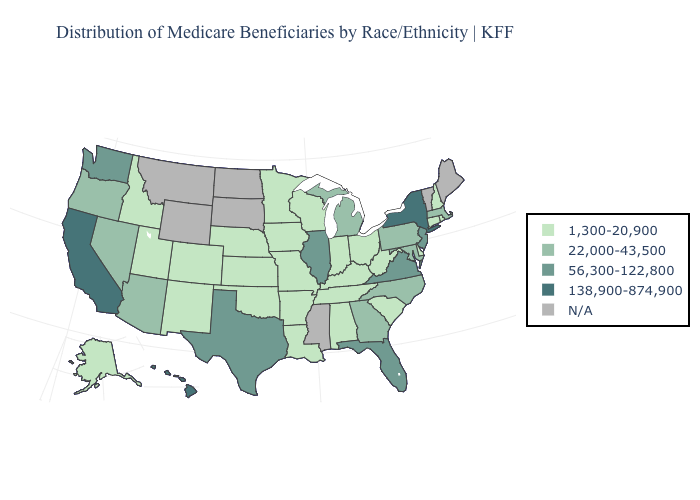Name the states that have a value in the range 1,300-20,900?
Give a very brief answer. Alabama, Alaska, Arkansas, Colorado, Connecticut, Delaware, Idaho, Indiana, Iowa, Kansas, Kentucky, Louisiana, Minnesota, Missouri, Nebraska, New Hampshire, New Mexico, Ohio, Oklahoma, Rhode Island, South Carolina, Tennessee, Utah, West Virginia, Wisconsin. Name the states that have a value in the range 1,300-20,900?
Answer briefly. Alabama, Alaska, Arkansas, Colorado, Connecticut, Delaware, Idaho, Indiana, Iowa, Kansas, Kentucky, Louisiana, Minnesota, Missouri, Nebraska, New Hampshire, New Mexico, Ohio, Oklahoma, Rhode Island, South Carolina, Tennessee, Utah, West Virginia, Wisconsin. Does New Jersey have the highest value in the Northeast?
Short answer required. No. Which states hav the highest value in the Northeast?
Give a very brief answer. New York. What is the lowest value in states that border Montana?
Concise answer only. 1,300-20,900. Does Georgia have the highest value in the USA?
Quick response, please. No. Is the legend a continuous bar?
Give a very brief answer. No. What is the value of Oregon?
Quick response, please. 22,000-43,500. Name the states that have a value in the range 138,900-874,900?
Be succinct. California, Hawaii, New York. Does Massachusetts have the highest value in the Northeast?
Concise answer only. No. What is the value of Vermont?
Concise answer only. N/A. What is the value of South Carolina?
Be succinct. 1,300-20,900. Among the states that border West Virginia , does Ohio have the lowest value?
Write a very short answer. Yes. 